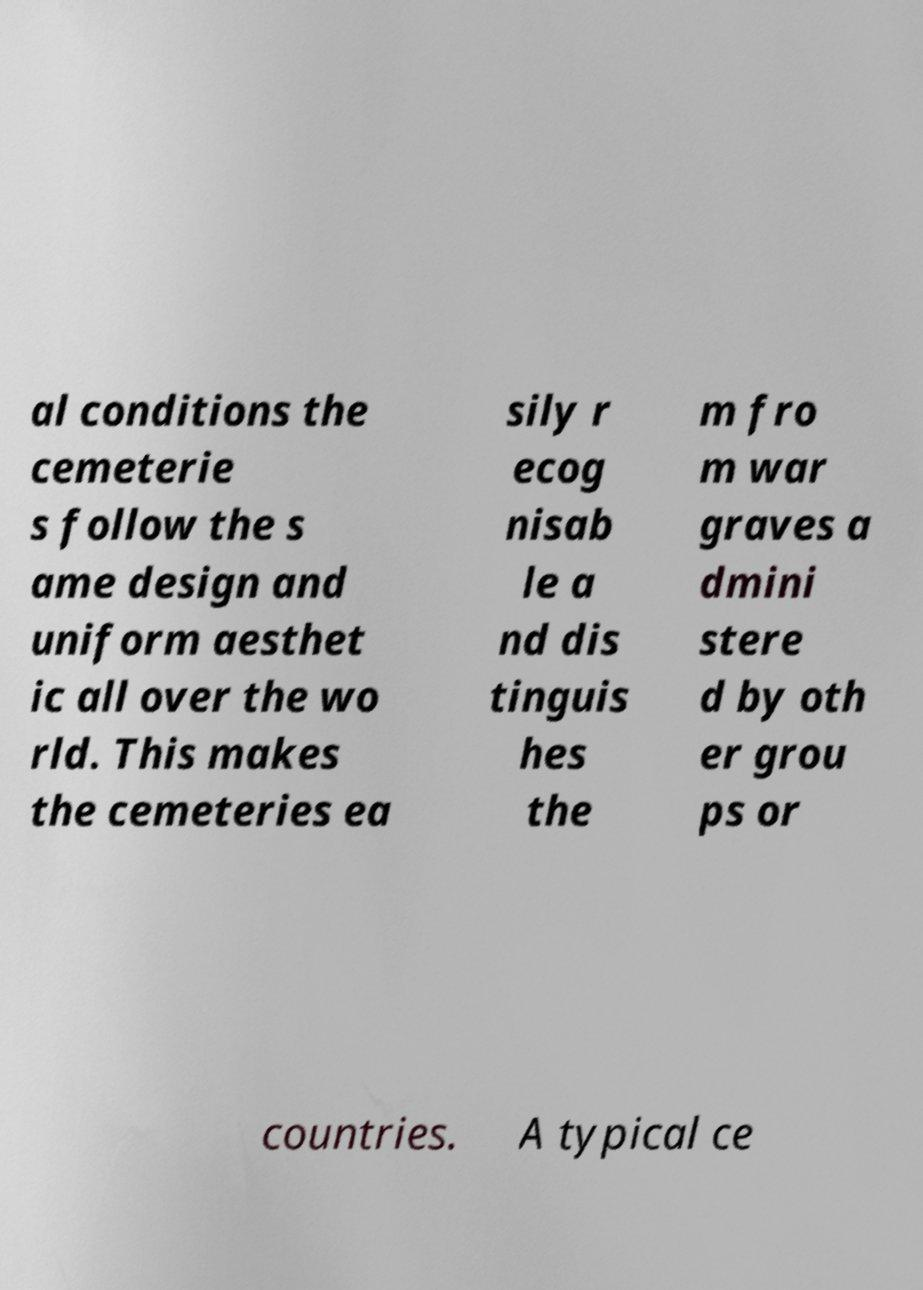Can you accurately transcribe the text from the provided image for me? al conditions the cemeterie s follow the s ame design and uniform aesthet ic all over the wo rld. This makes the cemeteries ea sily r ecog nisab le a nd dis tinguis hes the m fro m war graves a dmini stere d by oth er grou ps or countries. A typical ce 